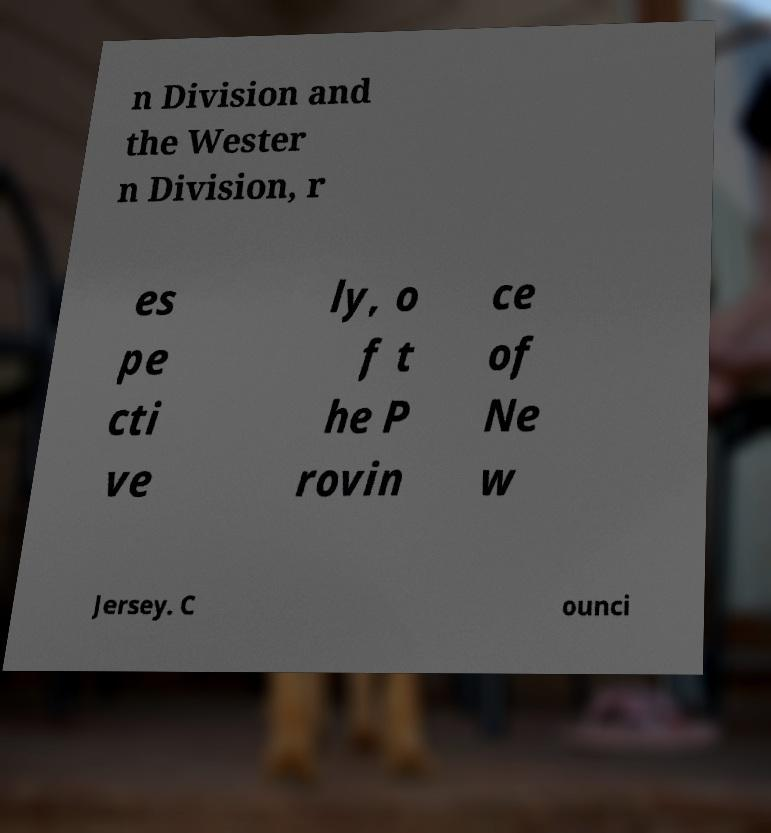Could you assist in decoding the text presented in this image and type it out clearly? n Division and the Wester n Division, r es pe cti ve ly, o f t he P rovin ce of Ne w Jersey. C ounci 